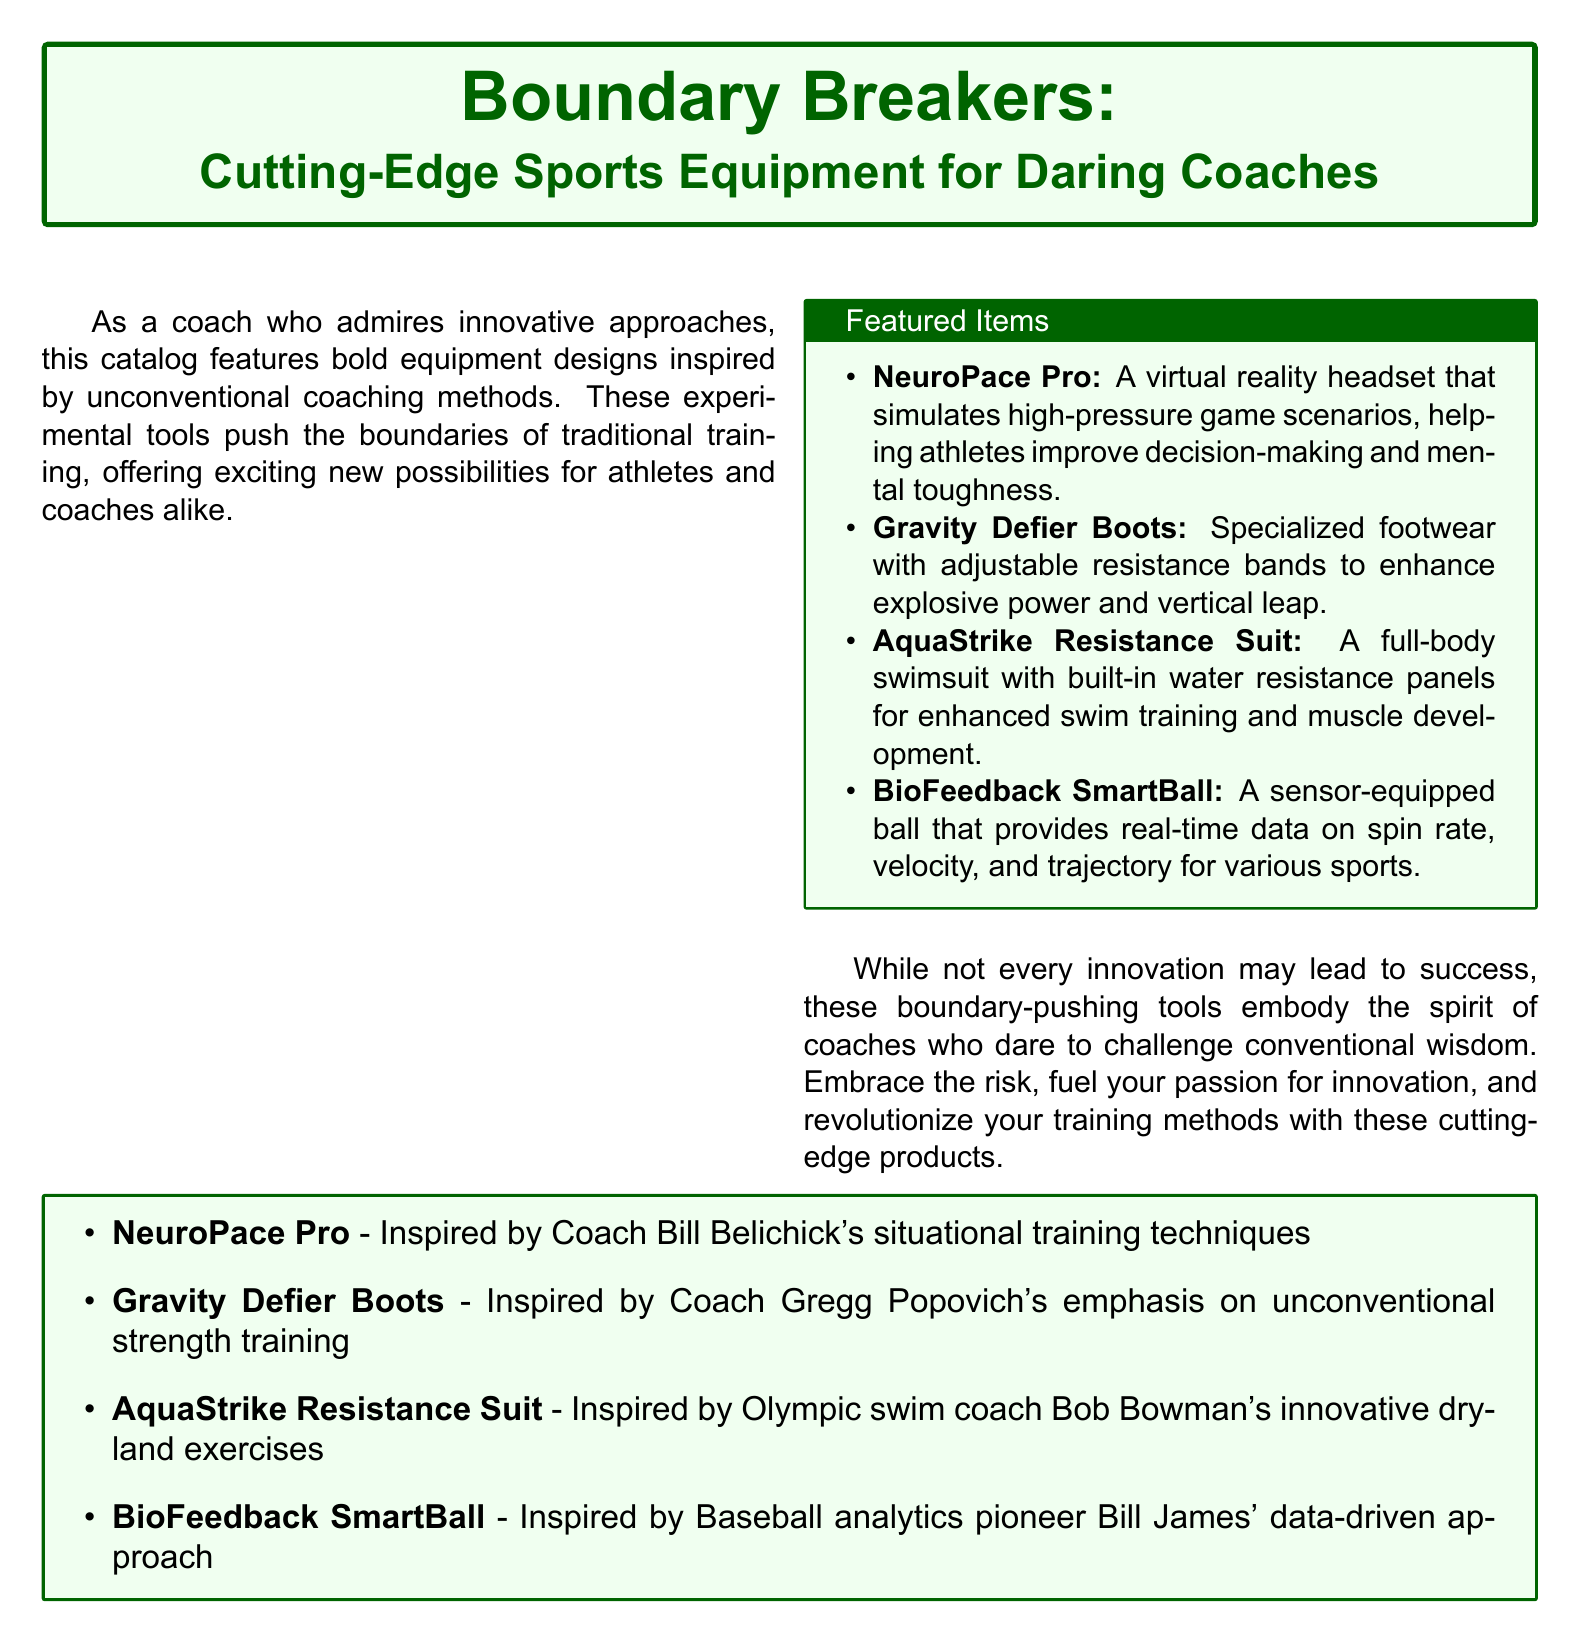What is the title of the catalog? The title of the catalog is presented at the top of the document.
Answer: Boundary Breakers How many featured items are listed? The document contains a box that lists the featured items within a bulleted format.
Answer: 4 What does the NeuroPace Pro simulate? The description of the NeuroPace Pro specifies that it simulates high-pressure game scenarios.
Answer: high-pressure game scenarios Which coach inspired the Gravity Defier Boots? The document includes an itemized list attributing each equipment to a specific coach's inspiration.
Answer: Coach Gregg Popovich What is the primary use of the AquaStrike Resistance Suit? The document outlines the main purpose of the AquaStrike Resistance Suit in its description.
Answer: swim training What unique feature does the BioFeedback SmartBall offer? The document states that the BioFeedback SmartBall provides real-time data on various metrics related to sports.
Answer: real-time data Which coaching method influenced the AquaStrike Resistance Suit? The document attributes the AquaStrike Resistance Suit to a specific coaching approach.
Answer: innovative dryland exercises What type of footwear are the Gravity Defier Boots? The document categorizes the Gravity Defier Boots under specialized footwear in its description.
Answer: specialized footwear 